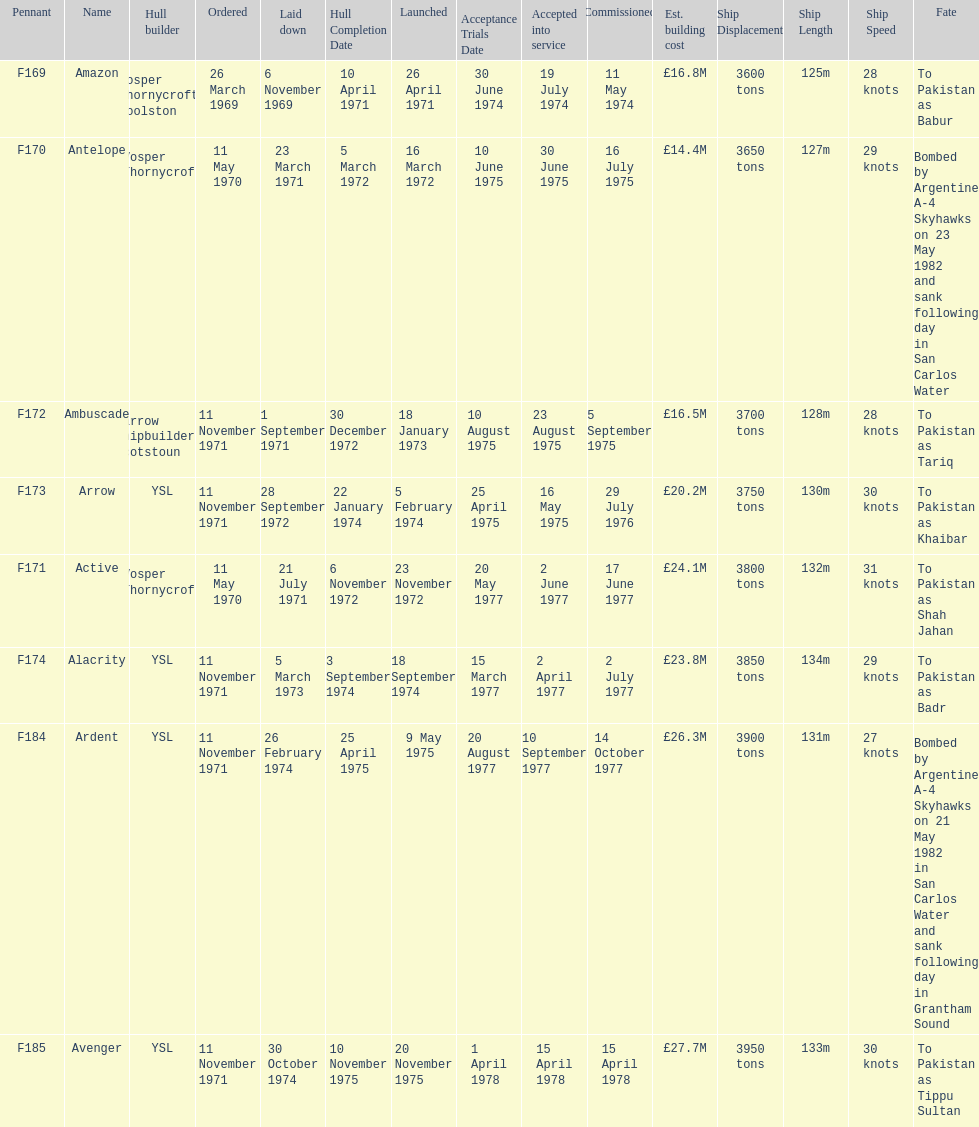What is the next pennant after f172? F173. 